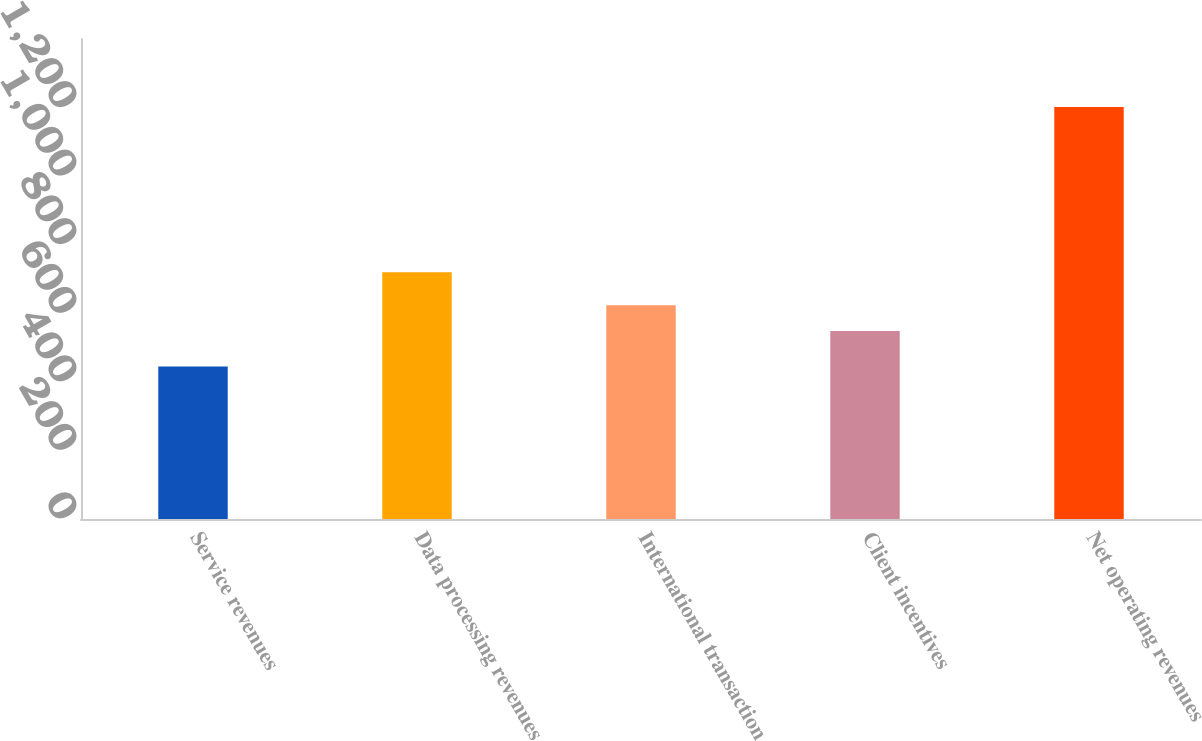Convert chart to OTSL. <chart><loc_0><loc_0><loc_500><loc_500><bar_chart><fcel>Service revenues<fcel>Data processing revenues<fcel>International transaction<fcel>Client incentives<fcel>Net operating revenues<nl><fcel>445<fcel>720<fcel>623.7<fcel>548<fcel>1202<nl></chart> 